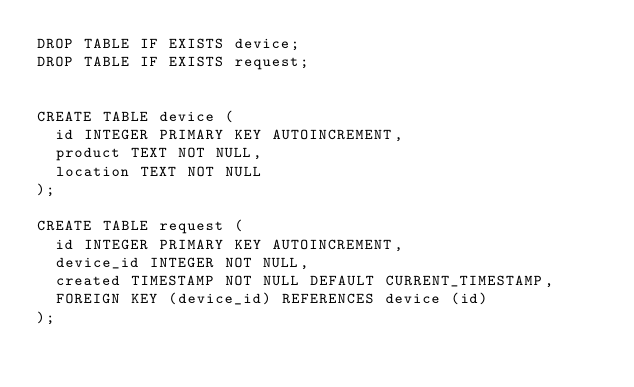<code> <loc_0><loc_0><loc_500><loc_500><_SQL_>DROP TABLE IF EXISTS device;
DROP TABLE IF EXISTS request;


CREATE TABLE device (
  id INTEGER PRIMARY KEY AUTOINCREMENT,
  product TEXT NOT NULL,
  location TEXT NOT NULL
);

CREATE TABLE request (
  id INTEGER PRIMARY KEY AUTOINCREMENT,
  device_id INTEGER NOT NULL,
  created TIMESTAMP NOT NULL DEFAULT CURRENT_TIMESTAMP,
  FOREIGN KEY (device_id) REFERENCES device (id)
);
</code> 